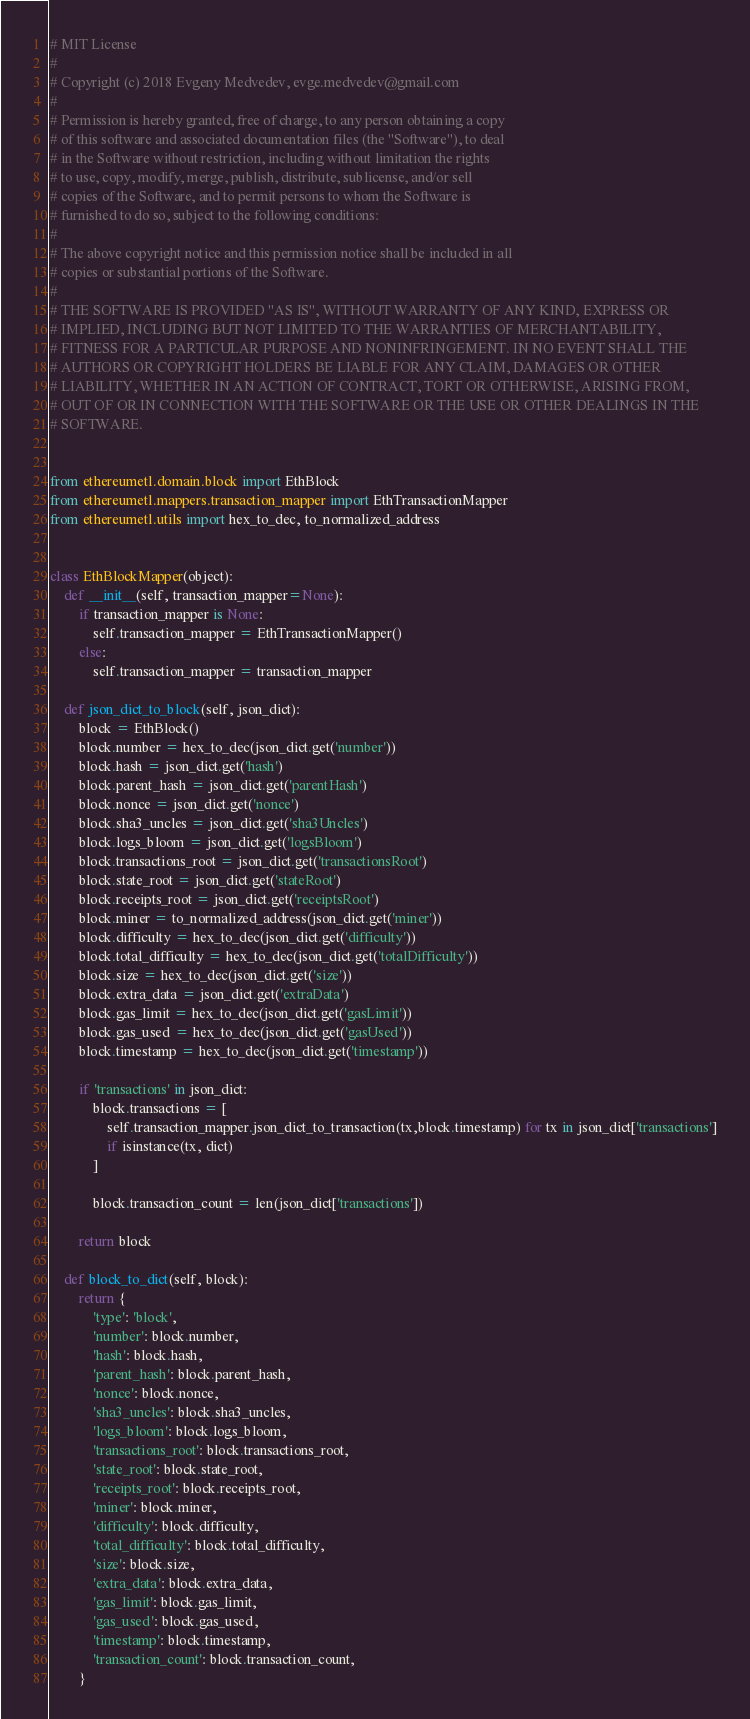<code> <loc_0><loc_0><loc_500><loc_500><_Python_># MIT License
#
# Copyright (c) 2018 Evgeny Medvedev, evge.medvedev@gmail.com
#
# Permission is hereby granted, free of charge, to any person obtaining a copy
# of this software and associated documentation files (the "Software"), to deal
# in the Software without restriction, including without limitation the rights
# to use, copy, modify, merge, publish, distribute, sublicense, and/or sell
# copies of the Software, and to permit persons to whom the Software is
# furnished to do so, subject to the following conditions:
#
# The above copyright notice and this permission notice shall be included in all
# copies or substantial portions of the Software.
#
# THE SOFTWARE IS PROVIDED "AS IS", WITHOUT WARRANTY OF ANY KIND, EXPRESS OR
# IMPLIED, INCLUDING BUT NOT LIMITED TO THE WARRANTIES OF MERCHANTABILITY,
# FITNESS FOR A PARTICULAR PURPOSE AND NONINFRINGEMENT. IN NO EVENT SHALL THE
# AUTHORS OR COPYRIGHT HOLDERS BE LIABLE FOR ANY CLAIM, DAMAGES OR OTHER
# LIABILITY, WHETHER IN AN ACTION OF CONTRACT, TORT OR OTHERWISE, ARISING FROM,
# OUT OF OR IN CONNECTION WITH THE SOFTWARE OR THE USE OR OTHER DEALINGS IN THE
# SOFTWARE.


from ethereumetl.domain.block import EthBlock
from ethereumetl.mappers.transaction_mapper import EthTransactionMapper
from ethereumetl.utils import hex_to_dec, to_normalized_address


class EthBlockMapper(object):
    def __init__(self, transaction_mapper=None):
        if transaction_mapper is None:
            self.transaction_mapper = EthTransactionMapper()
        else:
            self.transaction_mapper = transaction_mapper

    def json_dict_to_block(self, json_dict):
        block = EthBlock()
        block.number = hex_to_dec(json_dict.get('number'))
        block.hash = json_dict.get('hash')
        block.parent_hash = json_dict.get('parentHash')
        block.nonce = json_dict.get('nonce')
        block.sha3_uncles = json_dict.get('sha3Uncles')
        block.logs_bloom = json_dict.get('logsBloom')
        block.transactions_root = json_dict.get('transactionsRoot')
        block.state_root = json_dict.get('stateRoot')
        block.receipts_root = json_dict.get('receiptsRoot')
        block.miner = to_normalized_address(json_dict.get('miner'))
        block.difficulty = hex_to_dec(json_dict.get('difficulty'))
        block.total_difficulty = hex_to_dec(json_dict.get('totalDifficulty'))
        block.size = hex_to_dec(json_dict.get('size'))
        block.extra_data = json_dict.get('extraData')
        block.gas_limit = hex_to_dec(json_dict.get('gasLimit'))
        block.gas_used = hex_to_dec(json_dict.get('gasUsed'))
        block.timestamp = hex_to_dec(json_dict.get('timestamp'))

        if 'transactions' in json_dict:
            block.transactions = [
                self.transaction_mapper.json_dict_to_transaction(tx,block.timestamp) for tx in json_dict['transactions']
                if isinstance(tx, dict)
            ]

            block.transaction_count = len(json_dict['transactions'])

        return block

    def block_to_dict(self, block):
        return {
            'type': 'block',
            'number': block.number,
            'hash': block.hash,
            'parent_hash': block.parent_hash,
            'nonce': block.nonce,
            'sha3_uncles': block.sha3_uncles,
            'logs_bloom': block.logs_bloom,
            'transactions_root': block.transactions_root,
            'state_root': block.state_root,
            'receipts_root': block.receipts_root,
            'miner': block.miner,
            'difficulty': block.difficulty,
            'total_difficulty': block.total_difficulty,
            'size': block.size,
            'extra_data': block.extra_data,
            'gas_limit': block.gas_limit,
            'gas_used': block.gas_used,
            'timestamp': block.timestamp,
            'transaction_count': block.transaction_count,
        }
</code> 